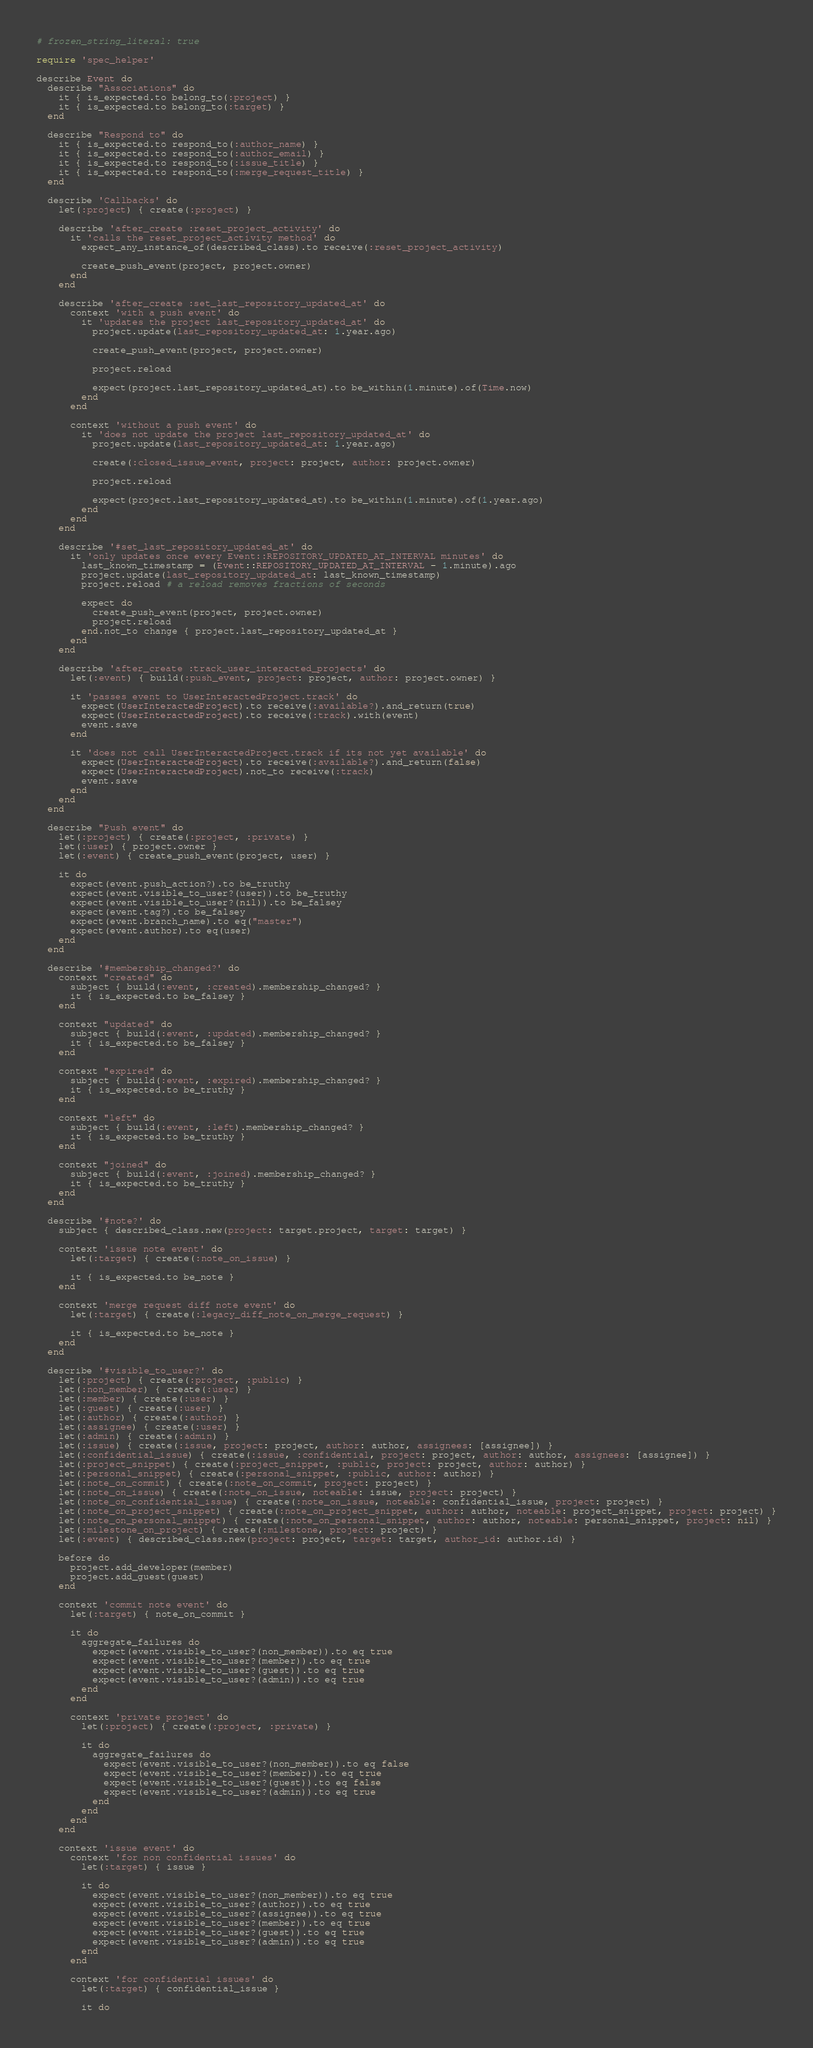<code> <loc_0><loc_0><loc_500><loc_500><_Ruby_># frozen_string_literal: true

require 'spec_helper'

describe Event do
  describe "Associations" do
    it { is_expected.to belong_to(:project) }
    it { is_expected.to belong_to(:target) }
  end

  describe "Respond to" do
    it { is_expected.to respond_to(:author_name) }
    it { is_expected.to respond_to(:author_email) }
    it { is_expected.to respond_to(:issue_title) }
    it { is_expected.to respond_to(:merge_request_title) }
  end

  describe 'Callbacks' do
    let(:project) { create(:project) }

    describe 'after_create :reset_project_activity' do
      it 'calls the reset_project_activity method' do
        expect_any_instance_of(described_class).to receive(:reset_project_activity)

        create_push_event(project, project.owner)
      end
    end

    describe 'after_create :set_last_repository_updated_at' do
      context 'with a push event' do
        it 'updates the project last_repository_updated_at' do
          project.update(last_repository_updated_at: 1.year.ago)

          create_push_event(project, project.owner)

          project.reload

          expect(project.last_repository_updated_at).to be_within(1.minute).of(Time.now)
        end
      end

      context 'without a push event' do
        it 'does not update the project last_repository_updated_at' do
          project.update(last_repository_updated_at: 1.year.ago)

          create(:closed_issue_event, project: project, author: project.owner)

          project.reload

          expect(project.last_repository_updated_at).to be_within(1.minute).of(1.year.ago)
        end
      end
    end

    describe '#set_last_repository_updated_at' do
      it 'only updates once every Event::REPOSITORY_UPDATED_AT_INTERVAL minutes' do
        last_known_timestamp = (Event::REPOSITORY_UPDATED_AT_INTERVAL - 1.minute).ago
        project.update(last_repository_updated_at: last_known_timestamp)
        project.reload # a reload removes fractions of seconds

        expect do
          create_push_event(project, project.owner)
          project.reload
        end.not_to change { project.last_repository_updated_at }
      end
    end

    describe 'after_create :track_user_interacted_projects' do
      let(:event) { build(:push_event, project: project, author: project.owner) }

      it 'passes event to UserInteractedProject.track' do
        expect(UserInteractedProject).to receive(:available?).and_return(true)
        expect(UserInteractedProject).to receive(:track).with(event)
        event.save
      end

      it 'does not call UserInteractedProject.track if its not yet available' do
        expect(UserInteractedProject).to receive(:available?).and_return(false)
        expect(UserInteractedProject).not_to receive(:track)
        event.save
      end
    end
  end

  describe "Push event" do
    let(:project) { create(:project, :private) }
    let(:user) { project.owner }
    let(:event) { create_push_event(project, user) }

    it do
      expect(event.push_action?).to be_truthy
      expect(event.visible_to_user?(user)).to be_truthy
      expect(event.visible_to_user?(nil)).to be_falsey
      expect(event.tag?).to be_falsey
      expect(event.branch_name).to eq("master")
      expect(event.author).to eq(user)
    end
  end

  describe '#membership_changed?' do
    context "created" do
      subject { build(:event, :created).membership_changed? }
      it { is_expected.to be_falsey }
    end

    context "updated" do
      subject { build(:event, :updated).membership_changed? }
      it { is_expected.to be_falsey }
    end

    context "expired" do
      subject { build(:event, :expired).membership_changed? }
      it { is_expected.to be_truthy }
    end

    context "left" do
      subject { build(:event, :left).membership_changed? }
      it { is_expected.to be_truthy }
    end

    context "joined" do
      subject { build(:event, :joined).membership_changed? }
      it { is_expected.to be_truthy }
    end
  end

  describe '#note?' do
    subject { described_class.new(project: target.project, target: target) }

    context 'issue note event' do
      let(:target) { create(:note_on_issue) }

      it { is_expected.to be_note }
    end

    context 'merge request diff note event' do
      let(:target) { create(:legacy_diff_note_on_merge_request) }

      it { is_expected.to be_note }
    end
  end

  describe '#visible_to_user?' do
    let(:project) { create(:project, :public) }
    let(:non_member) { create(:user) }
    let(:member) { create(:user) }
    let(:guest) { create(:user) }
    let(:author) { create(:author) }
    let(:assignee) { create(:user) }
    let(:admin) { create(:admin) }
    let(:issue) { create(:issue, project: project, author: author, assignees: [assignee]) }
    let(:confidential_issue) { create(:issue, :confidential, project: project, author: author, assignees: [assignee]) }
    let(:project_snippet) { create(:project_snippet, :public, project: project, author: author) }
    let(:personal_snippet) { create(:personal_snippet, :public, author: author) }
    let(:note_on_commit) { create(:note_on_commit, project: project) }
    let(:note_on_issue) { create(:note_on_issue, noteable: issue, project: project) }
    let(:note_on_confidential_issue) { create(:note_on_issue, noteable: confidential_issue, project: project) }
    let(:note_on_project_snippet) { create(:note_on_project_snippet, author: author, noteable: project_snippet, project: project) }
    let(:note_on_personal_snippet) { create(:note_on_personal_snippet, author: author, noteable: personal_snippet, project: nil) }
    let(:milestone_on_project) { create(:milestone, project: project) }
    let(:event) { described_class.new(project: project, target: target, author_id: author.id) }

    before do
      project.add_developer(member)
      project.add_guest(guest)
    end

    context 'commit note event' do
      let(:target) { note_on_commit }

      it do
        aggregate_failures do
          expect(event.visible_to_user?(non_member)).to eq true
          expect(event.visible_to_user?(member)).to eq true
          expect(event.visible_to_user?(guest)).to eq true
          expect(event.visible_to_user?(admin)).to eq true
        end
      end

      context 'private project' do
        let(:project) { create(:project, :private) }

        it do
          aggregate_failures do
            expect(event.visible_to_user?(non_member)).to eq false
            expect(event.visible_to_user?(member)).to eq true
            expect(event.visible_to_user?(guest)).to eq false
            expect(event.visible_to_user?(admin)).to eq true
          end
        end
      end
    end

    context 'issue event' do
      context 'for non confidential issues' do
        let(:target) { issue }

        it do
          expect(event.visible_to_user?(non_member)).to eq true
          expect(event.visible_to_user?(author)).to eq true
          expect(event.visible_to_user?(assignee)).to eq true
          expect(event.visible_to_user?(member)).to eq true
          expect(event.visible_to_user?(guest)).to eq true
          expect(event.visible_to_user?(admin)).to eq true
        end
      end

      context 'for confidential issues' do
        let(:target) { confidential_issue }

        it do</code> 